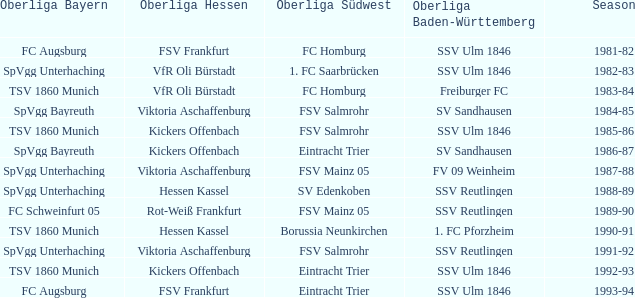During the 1991-92 season, which team was in the oberliga baden-württemberg? SSV Reutlingen. 